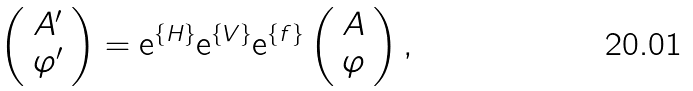<formula> <loc_0><loc_0><loc_500><loc_500>\left ( \begin{array} { c } A ^ { \prime } \\ \varphi ^ { \prime } \end{array} \right ) = { \mathrm e } ^ { \{ H \} } { \mathrm e } ^ { \{ V \} } { \mathrm e } ^ { \{ f \} } \left ( \begin{array} { c } A \\ \varphi \end{array} \right ) ,</formula> 